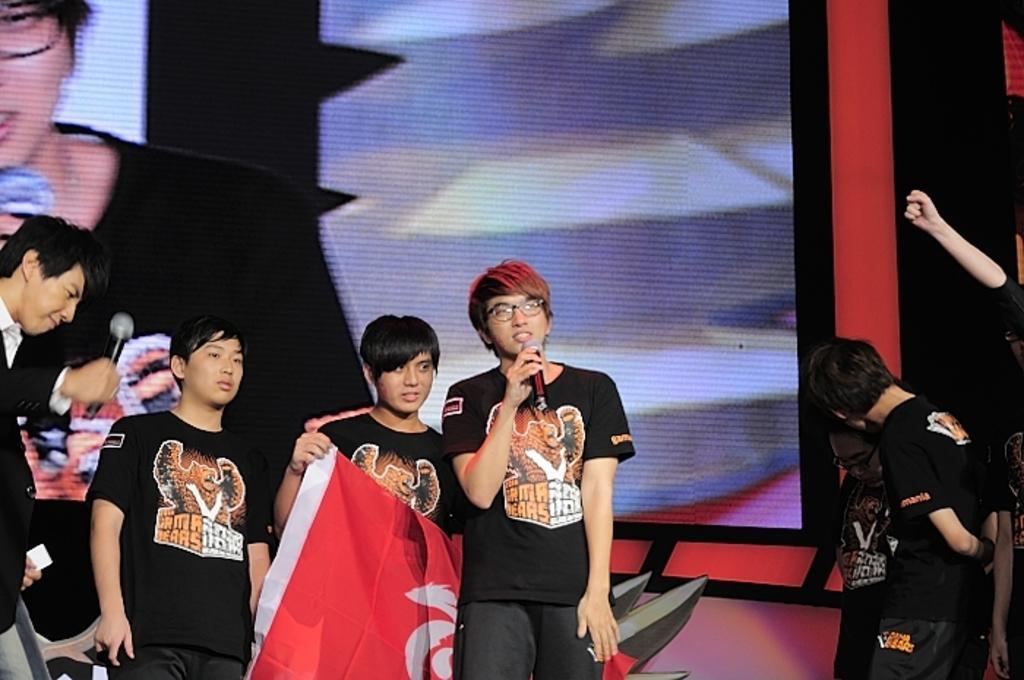Could you give a brief overview of what you see in this image? In this picture, we see six people are standing. The man in the middle is holding the microphone in his hand and he is talking on the microphone. Beside him, we see a man is holding the red color banner in his hands. On the left side, we see the man is holding a microphone. On the right side, we see two people are standing and we see the hand of the person. In the background, we see a wall and the screen which is displaying the image of the man who is holding the microphone. 